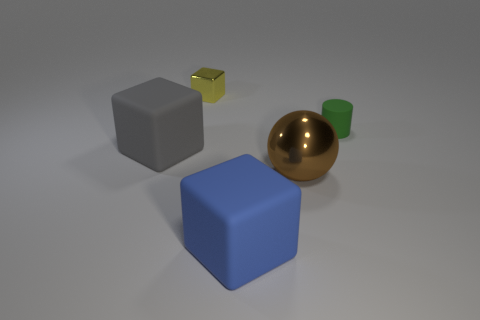Add 1 large gray rubber blocks. How many objects exist? 6 Subtract all spheres. How many objects are left? 4 Add 2 yellow shiny things. How many yellow shiny things are left? 3 Add 4 small metallic cubes. How many small metallic cubes exist? 5 Subtract 0 red cylinders. How many objects are left? 5 Subtract all tiny blocks. Subtract all large blocks. How many objects are left? 2 